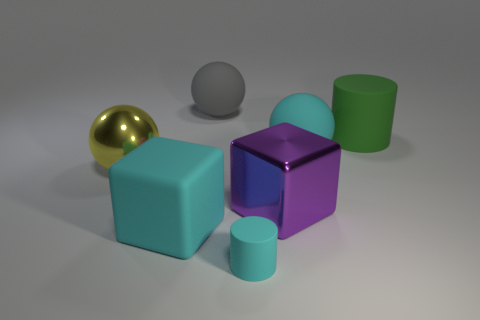Does the cyan cube have the same material as the ball behind the green object?
Offer a terse response. Yes. Are there fewer big shiny things on the right side of the big purple metal object than purple metal blocks to the right of the green rubber cylinder?
Your answer should be very brief. No. What is the color of the other small object that is the same material as the gray thing?
Provide a short and direct response. Cyan. There is a large matte sphere in front of the green rubber object; is there a big yellow metal ball right of it?
Your answer should be compact. No. What is the color of the rubber block that is the same size as the green matte cylinder?
Provide a short and direct response. Cyan. How many things are either purple shiny cubes or big things?
Give a very brief answer. 6. There is a cyan rubber thing on the left side of the cylinder in front of the large cyan thing that is on the right side of the gray thing; how big is it?
Make the answer very short. Large. What number of big metal blocks have the same color as the big matte cylinder?
Keep it short and to the point. 0. How many purple blocks are the same material as the gray object?
Ensure brevity in your answer.  0. How many objects are either tiny blue balls or things to the right of the shiny ball?
Your answer should be compact. 6. 